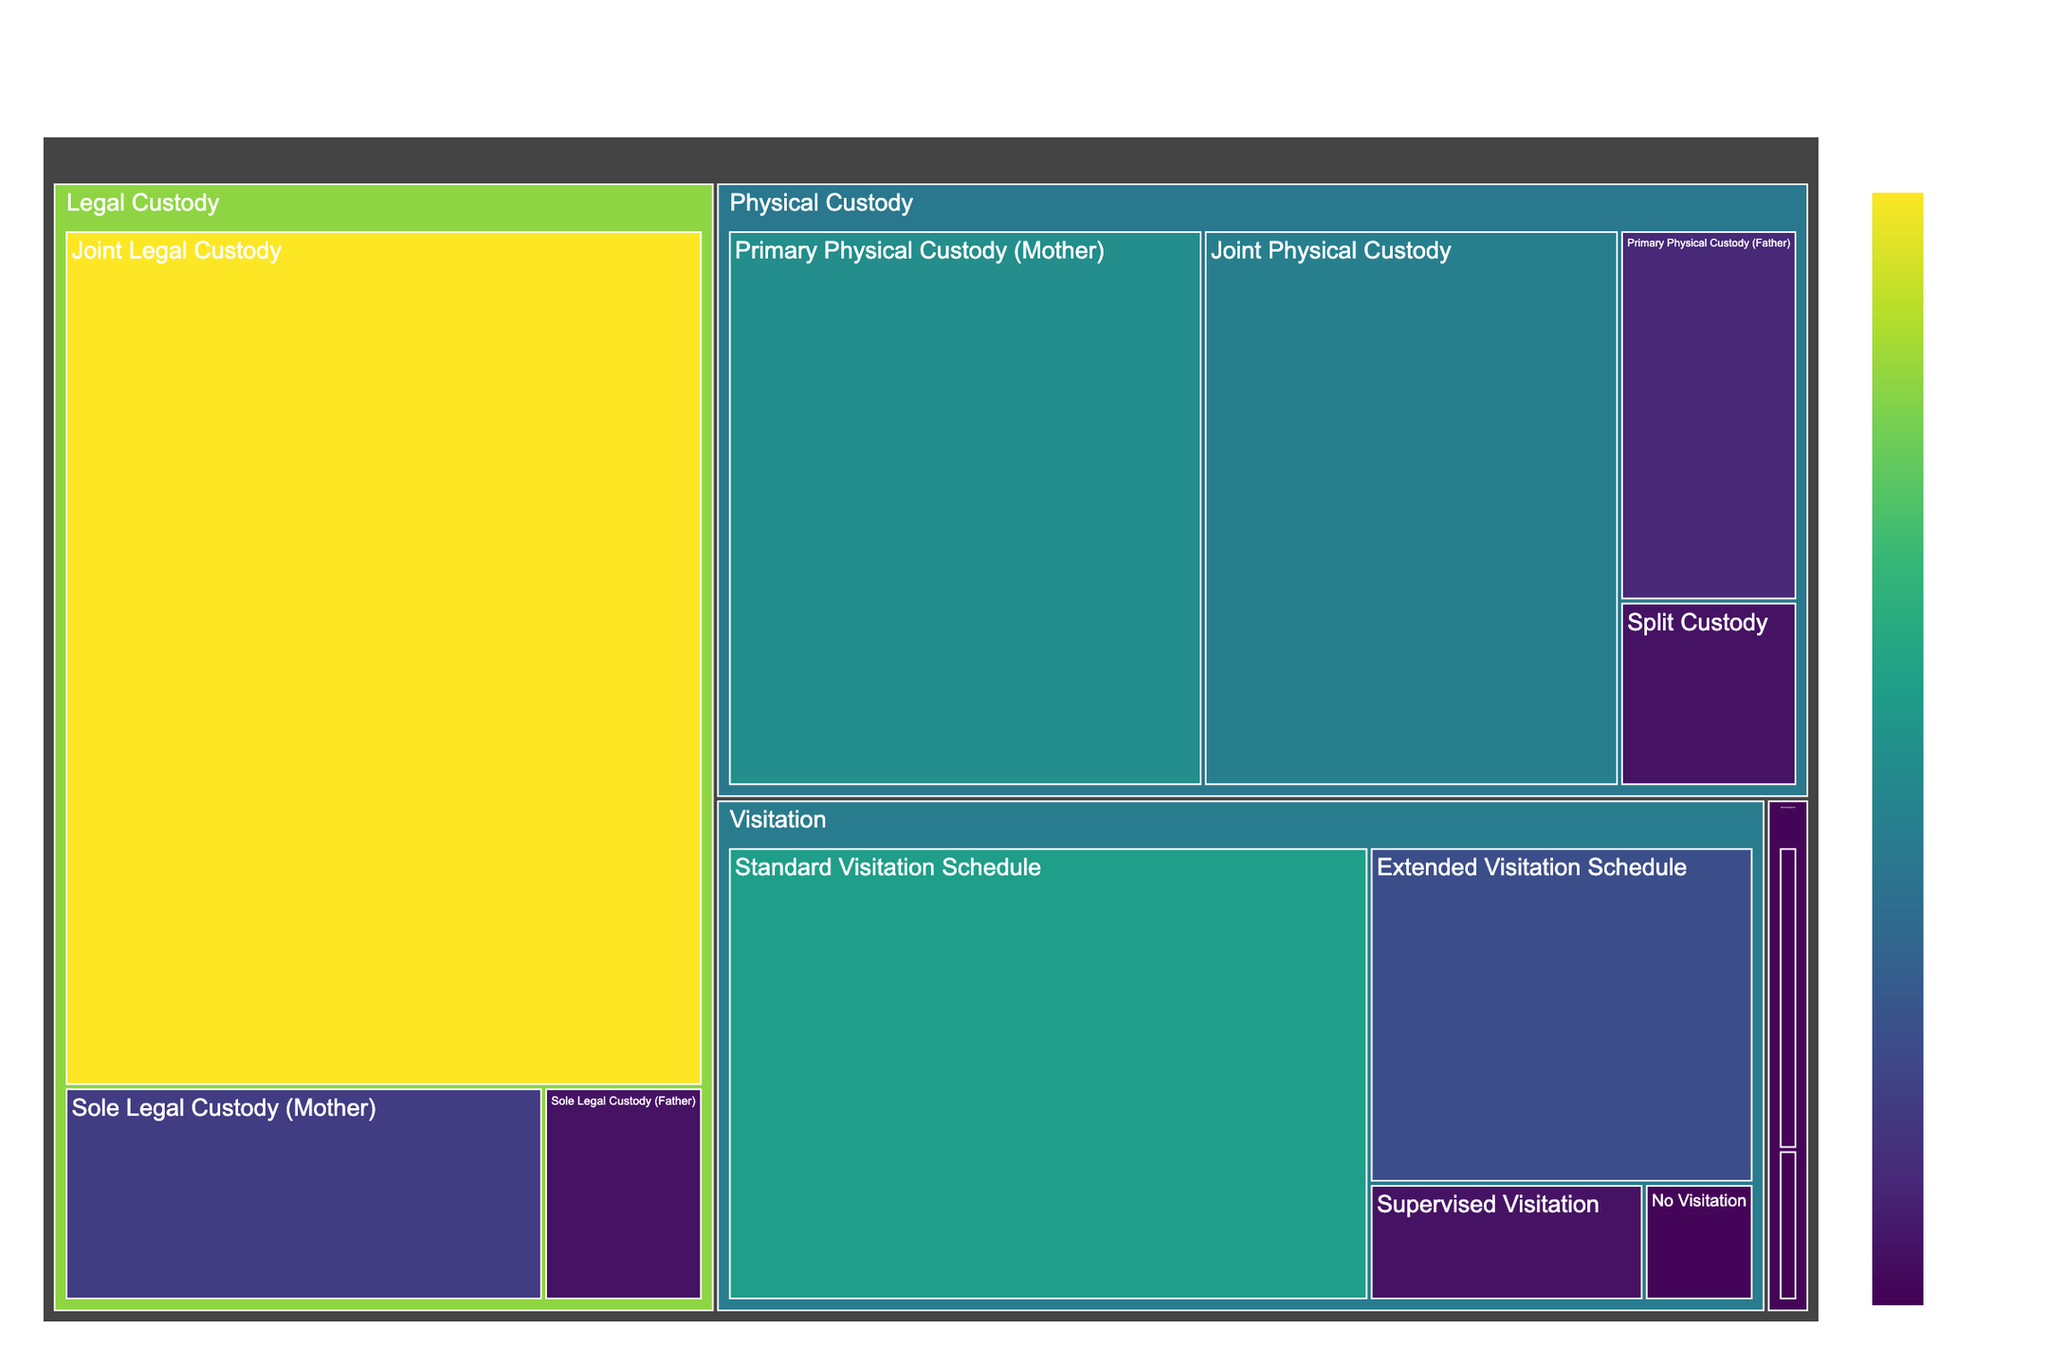What type of custody has the highest percentage for physical custody? The section labeled "Primary Physical Custody (Mother)" under "Physical Custody" occupies the largest area and shows a percentage of 40.
Answer: Primary Physical Custody (Mother) Which custody arrangement has the lowest percentage in the Visitation category? By looking at the "Visitation" category, the smallest section is "No Visitation," which represents 2%.
Answer: No Visitation What is the combined percentage of Joint Legal Custody and Sole Legal Custody (Mother)? By adding the percentages of "Joint Legal Custody" (80%) and "Sole Legal Custody (Mother)" (15%), we get 80 + 15 = 95%.
Answer: 95% How does the percentage of Joint Physical Custody compare to Primary Physical Custody (Father)? The percentage of "Joint Physical Custody" (35%) is greater than "Primary Physical Custody (Father)" (10%).
Answer: Greater What's the total percentage of arrangements falling under the Special Arrangements category? Summing up the percentages: "Bird's Nest Custody" (1%) and "Third-Party Custody" (2%) yields 1 + 2 = 3%.
Answer: 3% Which arrangement in the Physical Custody category has a percentage closest to 10%? The arrangement "Primary Physical Custody (Father)" has exactly 10%.
Answer: Primary Physical Custody (Father) What is the average percentage of the visitation arrangements? Adding the percentages: "Standard Visitation Schedule" (45%), "Extended Visitation Schedule" (20%), "Supervised Visitation" (5%), "No Visitation" (2%), then dividing by 4: (45 + 20 + 5 + 2) / 4 = 72 / 4 = 18%.
Answer: 18% Is Sole Legal Custody (Father) more or less common than Supervised Visitation? Both "Sole Legal Custody (Father)" and "Supervised Visitation" share the same percentage of 5%.
Answer: Equal What is the title of the treemap? The title displayed at the top of the treemap is 'Distribution of Child Custody Arrangements in the US'.
Answer: Distribution of Child Custody Arrangements in the US 